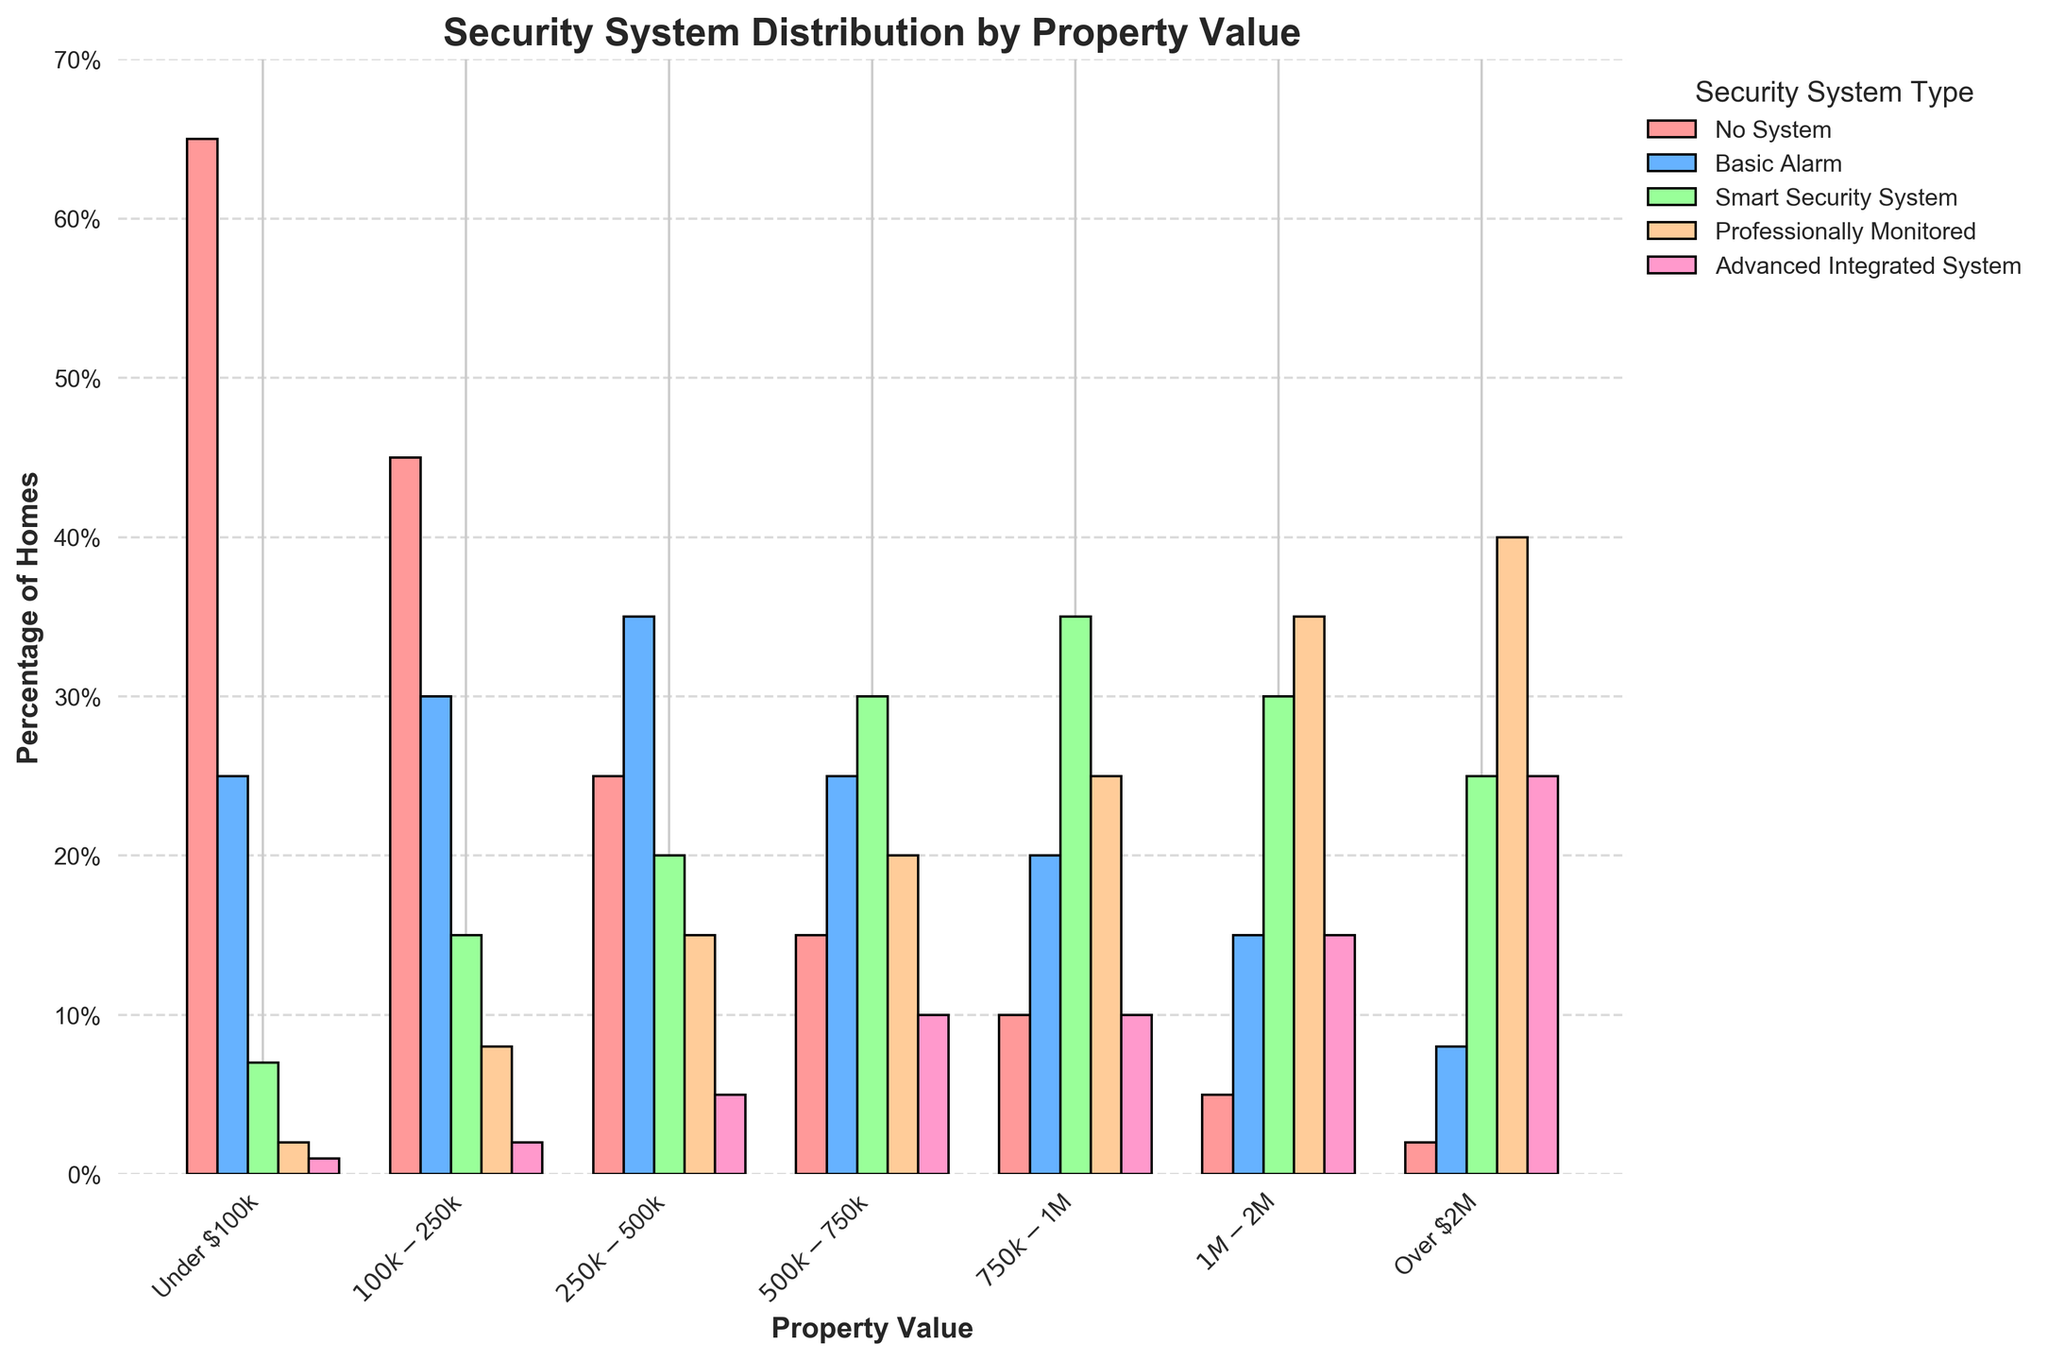Which property value category has the highest percentage of homes with no security system? The bar for "Under $100k" is the tallest in the 'No System' category, which means it has the highest percentage of homes without a security system.
Answer: Under $100k What is the total percentage of homes with a smart security system in the $100k-$250k category and the $250k-$500k category combined? In the $100k-$250k category, the percentage is 15%. In the $250k-$500k category, it is 20%. Adding them together, 15% + 20% = 35%.
Answer: 35% Which property value category has the highest usage of professionally monitored systems? The bar for "Over $2M" is the tallest in the 'Professionally Monitored' category, indicating the highest percentage.
Answer: Over $2M How does the percentage of homes with an advanced integrated system in the $500k-$750k category compare to the percentage in the $1M-$2M category? In the $500k-$750k category, the percentage is 10%, and for the $1M-$2M category, it is 15%. The $1M-$2M category has a higher percentage.
Answer: The $1M-$2M category has a higher percentage What is the average percentage of homes with a basic alarm in the categories "Under $100k" and "$500k-$750k"? The "Under $100k" category has 25%, and the "$500k-$750k" category has 25%. The average is (25% + 25%) / 2 = 25%.
Answer: 25% In which property value category do homes with smart security systems outnumber those with basic alarm systems? The "$750k-$1M" category shows a taller bar for the 'Smart Security System' (35%) compared to the 'Basic Alarm' (20%), indicating more smart systems.
Answer: $750k-$1M Which type of security system is least common in homes valued "Over $2M"? The smallest bar in the "Over $2M" category is for 'No System' at 2%, making it the least common.
Answer: No System In the "Under $100k" category, what is the combined percentage of homes with either a basic alarm or a smart security system? The percentage for 'Basic Alarm' is 25%, and for 'Smart Security System' it is 7%. Adding them together, 25% + 7% = 32%.
Answer: 32% How does the percentage of homes without any security system differ between the "$250k-$500k" and "$100k-$250k" categories? The $250k-$500k category has 25% and the $100k-$250k category has 45%. The difference is 45% - 25% = 20%.
Answer: 20% What is the percentage difference between homes with advanced integrated systems and professionally monitored systems in the "$750k-$1M" category? The percentage for advanced integrated systems is 10%, and for professionally monitored systems, it is 25%. The difference is 25% - 10% = 15%.
Answer: 15% Which property value category shows the most balanced distribution (least variation) among the different types of security systems? The category "$1M-$2M" shows relatively similar bars for all systems, indicating a more balanced distribution.
Answer: $1M-$2M 